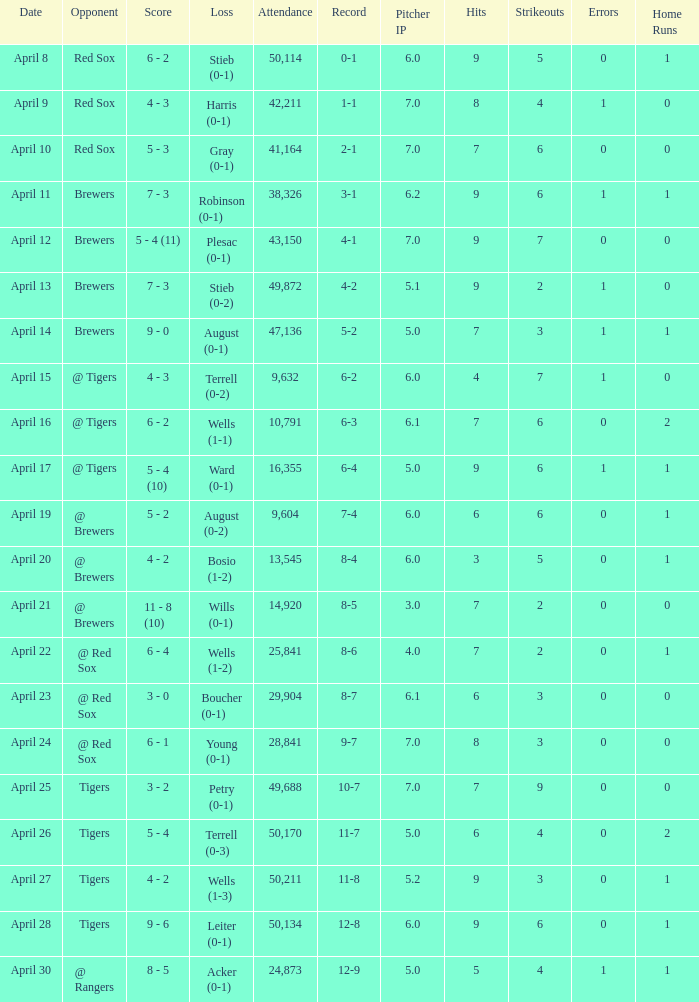Which loss has an attendance greater than 49,688 and 11-8 as the record? Wells (1-3). Could you help me parse every detail presented in this table? {'header': ['Date', 'Opponent', 'Score', 'Loss', 'Attendance', 'Record', 'Pitcher IP', 'Hits', 'Strikeouts', 'Errors', 'Home Runs'], 'rows': [['April 8', 'Red Sox', '6 - 2', 'Stieb (0-1)', '50,114', '0-1', '6.0', '9', '5', '0', '1'], ['April 9', 'Red Sox', '4 - 3', 'Harris (0-1)', '42,211', '1-1', '7.0', '8', '4', '1', '0'], ['April 10', 'Red Sox', '5 - 3', 'Gray (0-1)', '41,164', '2-1', '7.0', '7', '6', '0', '0'], ['April 11', 'Brewers', '7 - 3', 'Robinson (0-1)', '38,326', '3-1', '6.2', '9', '6', '1', '1'], ['April 12', 'Brewers', '5 - 4 (11)', 'Plesac (0-1)', '43,150', '4-1', '7.0', '9', '7', '0', '0'], ['April 13', 'Brewers', '7 - 3', 'Stieb (0-2)', '49,872', '4-2', '5.1', '9', '2', '1', '0'], ['April 14', 'Brewers', '9 - 0', 'August (0-1)', '47,136', '5-2', '5.0', '7', '3', '1', '1'], ['April 15', '@ Tigers', '4 - 3', 'Terrell (0-2)', '9,632', '6-2', '6.0', '4', '7', '1', '0'], ['April 16', '@ Tigers', '6 - 2', 'Wells (1-1)', '10,791', '6-3', '6.1', '7', '6', '0', '2'], ['April 17', '@ Tigers', '5 - 4 (10)', 'Ward (0-1)', '16,355', '6-4', '5.0', '9', '6', '1', '1'], ['April 19', '@ Brewers', '5 - 2', 'August (0-2)', '9,604', '7-4', '6.0', '6', '6', '0', '1'], ['April 20', '@ Brewers', '4 - 2', 'Bosio (1-2)', '13,545', '8-4', '6.0', '3', '5', '0', '1'], ['April 21', '@ Brewers', '11 - 8 (10)', 'Wills (0-1)', '14,920', '8-5', '3.0', '7', '2', '0', '0'], ['April 22', '@ Red Sox', '6 - 4', 'Wells (1-2)', '25,841', '8-6', '4.0', '7', '2', '0', '1'], ['April 23', '@ Red Sox', '3 - 0', 'Boucher (0-1)', '29,904', '8-7', '6.1', '6', '3', '0', '0'], ['April 24', '@ Red Sox', '6 - 1', 'Young (0-1)', '28,841', '9-7', '7.0', '8', '3', '0', '0'], ['April 25', 'Tigers', '3 - 2', 'Petry (0-1)', '49,688', '10-7', '7.0', '7', '9', '0', '0'], ['April 26', 'Tigers', '5 - 4', 'Terrell (0-3)', '50,170', '11-7', '5.0', '6', '4', '0', '2'], ['April 27', 'Tigers', '4 - 2', 'Wells (1-3)', '50,211', '11-8', '5.2', '9', '3', '0', '1'], ['April 28', 'Tigers', '9 - 6', 'Leiter (0-1)', '50,134', '12-8', '6.0', '9', '6', '0', '1'], ['April 30', '@ Rangers', '8 - 5', 'Acker (0-1)', '24,873', '12-9', '5.0', '5', '4', '1', '1']]} 